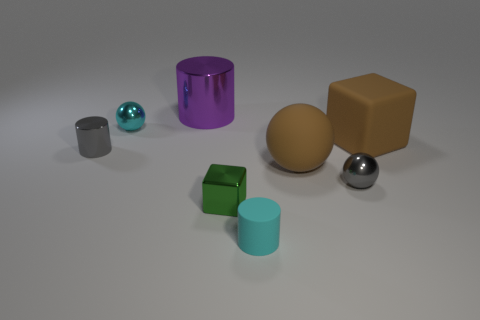Subtract all metallic cylinders. How many cylinders are left? 1 Add 2 balls. How many objects exist? 10 Subtract 0 blue blocks. How many objects are left? 8 Subtract all cubes. How many objects are left? 6 Subtract 2 cubes. How many cubes are left? 0 Subtract all purple spheres. Subtract all purple cylinders. How many spheres are left? 3 Subtract all yellow blocks. How many purple cylinders are left? 1 Subtract all cyan shiny spheres. Subtract all tiny balls. How many objects are left? 5 Add 8 gray things. How many gray things are left? 10 Add 8 shiny cylinders. How many shiny cylinders exist? 10 